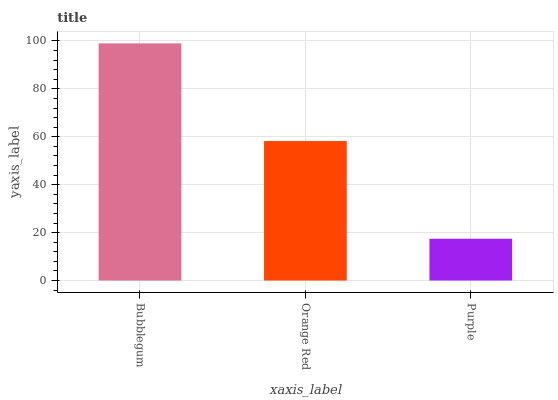Is Purple the minimum?
Answer yes or no. Yes. Is Bubblegum the maximum?
Answer yes or no. Yes. Is Orange Red the minimum?
Answer yes or no. No. Is Orange Red the maximum?
Answer yes or no. No. Is Bubblegum greater than Orange Red?
Answer yes or no. Yes. Is Orange Red less than Bubblegum?
Answer yes or no. Yes. Is Orange Red greater than Bubblegum?
Answer yes or no. No. Is Bubblegum less than Orange Red?
Answer yes or no. No. Is Orange Red the high median?
Answer yes or no. Yes. Is Orange Red the low median?
Answer yes or no. Yes. Is Purple the high median?
Answer yes or no. No. Is Purple the low median?
Answer yes or no. No. 